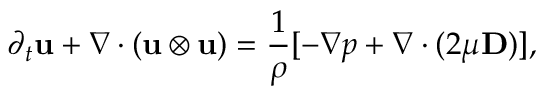<formula> <loc_0><loc_0><loc_500><loc_500>\partial _ { t } u + \nabla \cdot ( u \otimes u ) = \frac { 1 } { \rho } [ - \nabla p + \nabla \cdot ( 2 \mu D ) ] ,</formula> 